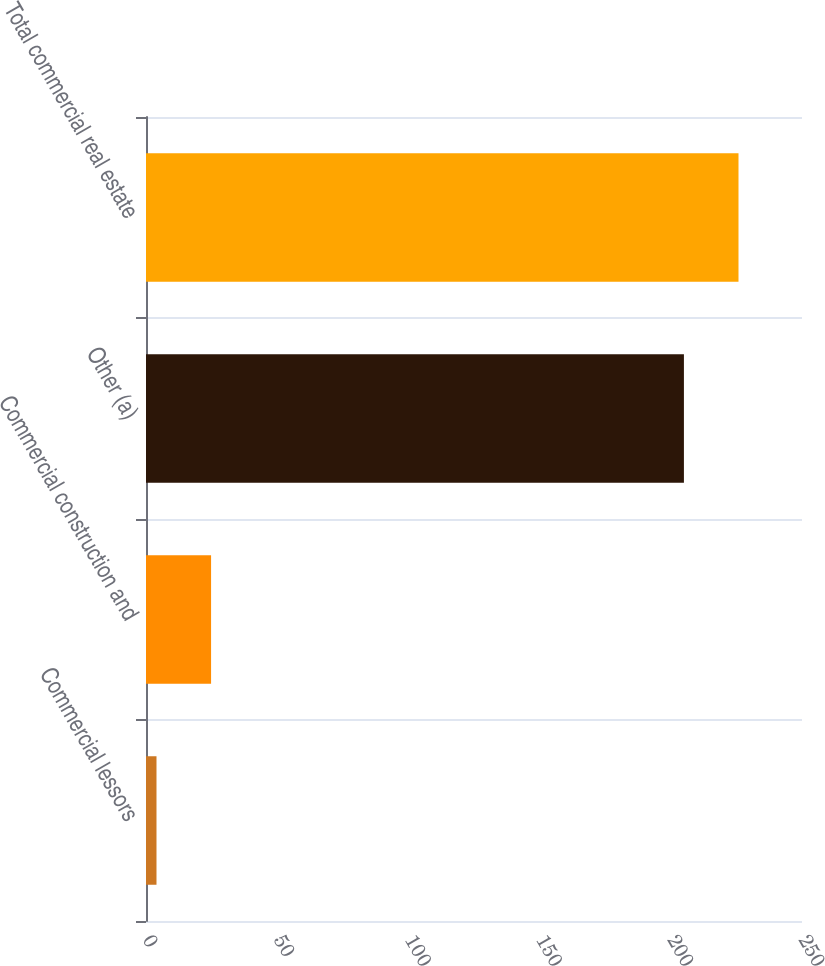<chart> <loc_0><loc_0><loc_500><loc_500><bar_chart><fcel>Commercial lessors<fcel>Commercial construction and<fcel>Other (a)<fcel>Total commercial real estate<nl><fcel>4<fcel>24.8<fcel>205<fcel>225.8<nl></chart> 